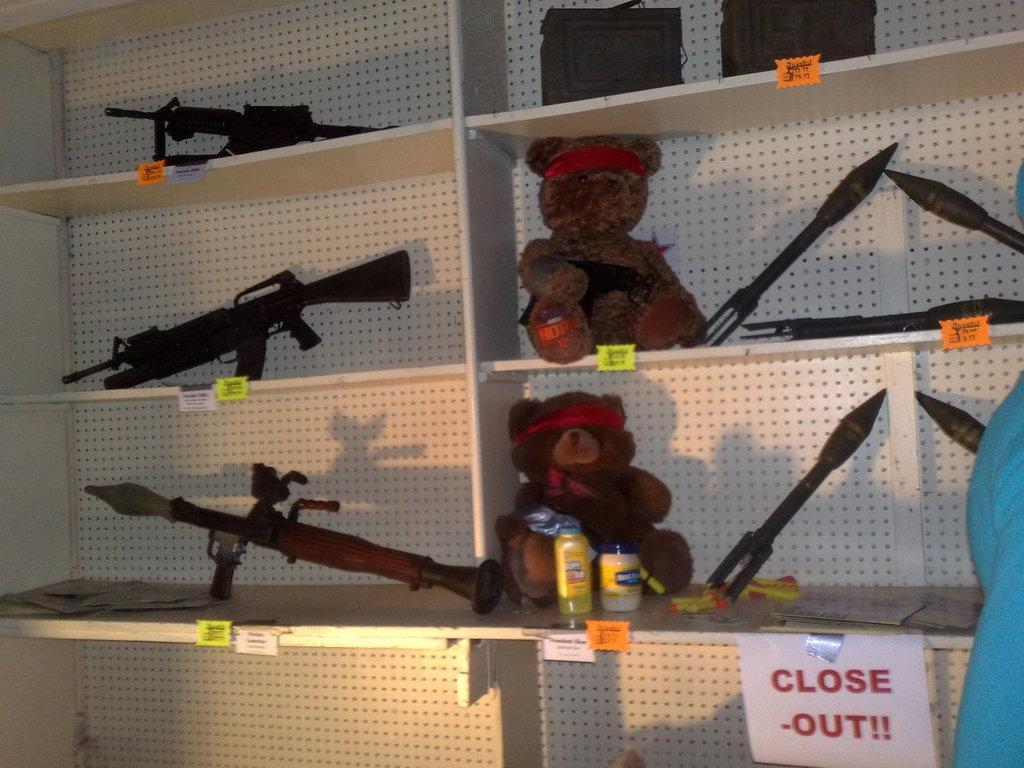How would you summarize this image in a sentence or two? In this image, we can see a rack contains teddy bears, bottles, guns and missiles. There are bags at the top of the image. 